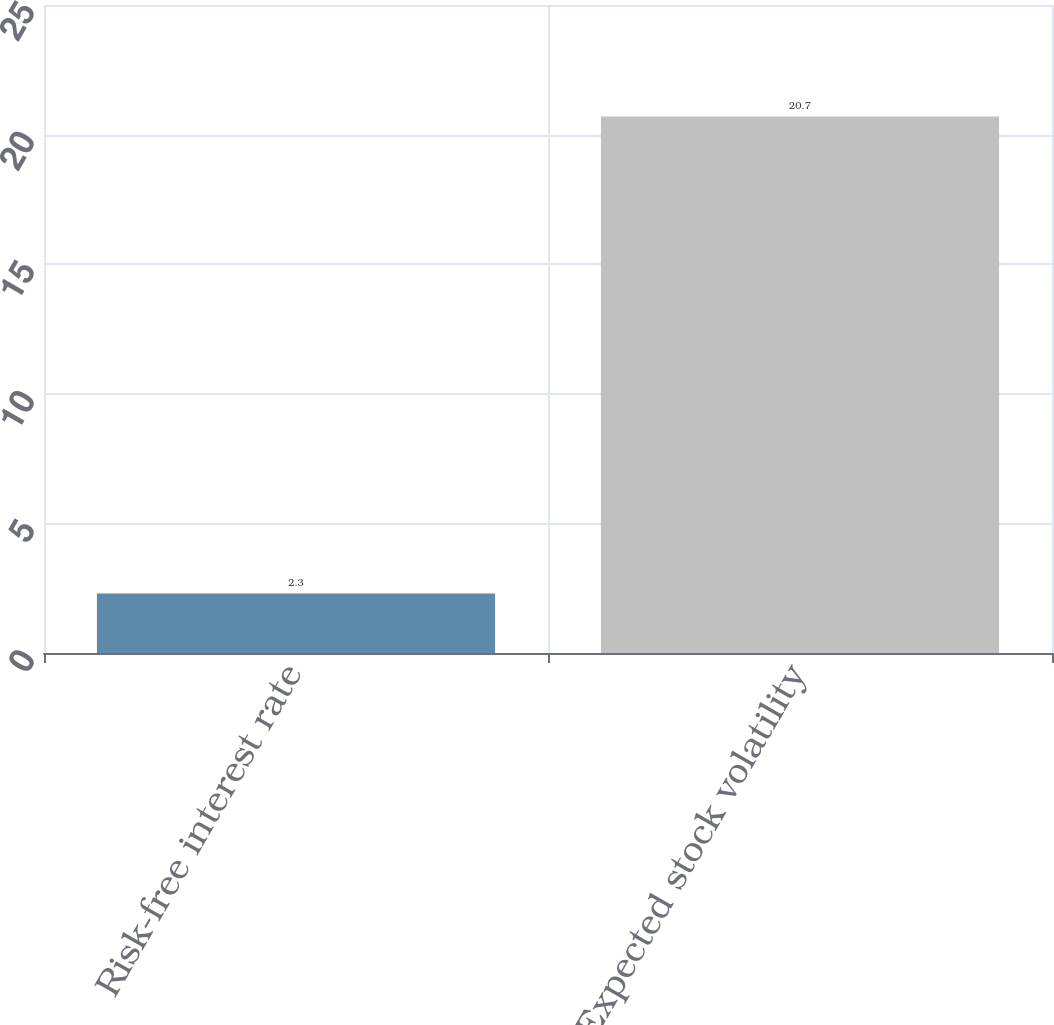Convert chart. <chart><loc_0><loc_0><loc_500><loc_500><bar_chart><fcel>Risk-free interest rate<fcel>Expected stock volatility<nl><fcel>2.3<fcel>20.7<nl></chart> 